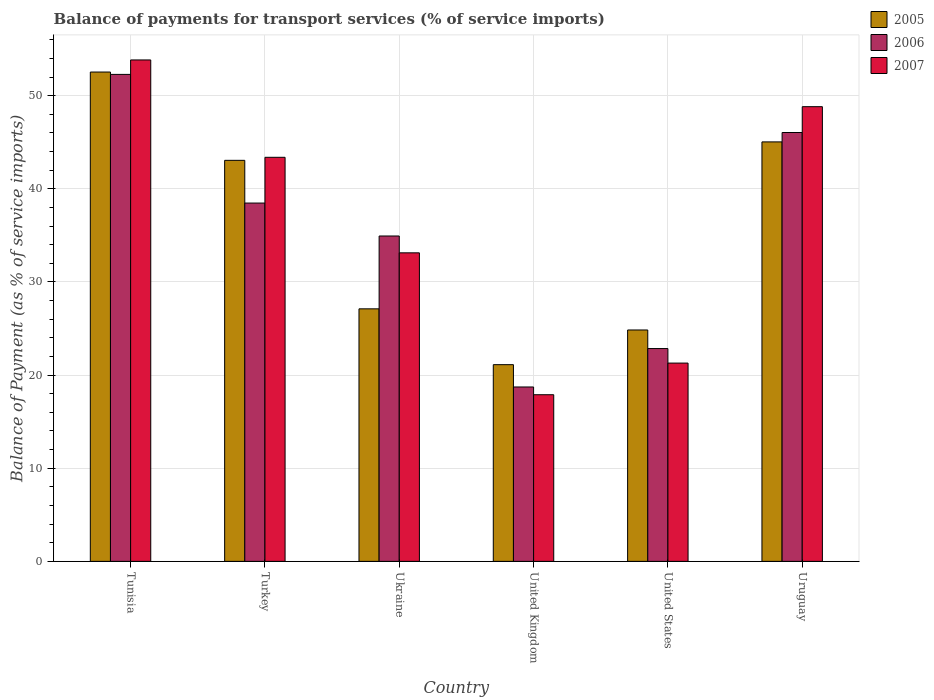How many different coloured bars are there?
Your answer should be compact. 3. Are the number of bars on each tick of the X-axis equal?
Provide a short and direct response. Yes. What is the label of the 6th group of bars from the left?
Keep it short and to the point. Uruguay. What is the balance of payments for transport services in 2007 in Ukraine?
Offer a terse response. 33.13. Across all countries, what is the maximum balance of payments for transport services in 2007?
Provide a short and direct response. 53.84. Across all countries, what is the minimum balance of payments for transport services in 2007?
Provide a succinct answer. 17.89. In which country was the balance of payments for transport services in 2006 maximum?
Your answer should be very brief. Tunisia. In which country was the balance of payments for transport services in 2007 minimum?
Your response must be concise. United Kingdom. What is the total balance of payments for transport services in 2006 in the graph?
Provide a short and direct response. 213.33. What is the difference between the balance of payments for transport services in 2006 in Tunisia and that in United Kingdom?
Your answer should be compact. 33.57. What is the difference between the balance of payments for transport services in 2005 in Uruguay and the balance of payments for transport services in 2006 in United Kingdom?
Your answer should be very brief. 26.32. What is the average balance of payments for transport services in 2007 per country?
Ensure brevity in your answer.  36.39. What is the difference between the balance of payments for transport services of/in 2007 and balance of payments for transport services of/in 2006 in Tunisia?
Provide a short and direct response. 1.55. In how many countries, is the balance of payments for transport services in 2005 greater than 22 %?
Make the answer very short. 5. What is the ratio of the balance of payments for transport services in 2007 in Turkey to that in Ukraine?
Keep it short and to the point. 1.31. Is the difference between the balance of payments for transport services in 2007 in United Kingdom and United States greater than the difference between the balance of payments for transport services in 2006 in United Kingdom and United States?
Provide a short and direct response. Yes. What is the difference between the highest and the second highest balance of payments for transport services in 2006?
Offer a very short reply. -13.82. What is the difference between the highest and the lowest balance of payments for transport services in 2007?
Give a very brief answer. 35.95. In how many countries, is the balance of payments for transport services in 2007 greater than the average balance of payments for transport services in 2007 taken over all countries?
Keep it short and to the point. 3. Is the sum of the balance of payments for transport services in 2005 in Ukraine and United Kingdom greater than the maximum balance of payments for transport services in 2007 across all countries?
Offer a terse response. No. What does the 2nd bar from the left in Uruguay represents?
Give a very brief answer. 2006. What does the 2nd bar from the right in Uruguay represents?
Provide a short and direct response. 2006. Is it the case that in every country, the sum of the balance of payments for transport services in 2006 and balance of payments for transport services in 2007 is greater than the balance of payments for transport services in 2005?
Offer a terse response. Yes. How many bars are there?
Make the answer very short. 18. Are the values on the major ticks of Y-axis written in scientific E-notation?
Your answer should be very brief. No. Does the graph contain any zero values?
Your answer should be compact. No. How many legend labels are there?
Provide a short and direct response. 3. How are the legend labels stacked?
Ensure brevity in your answer.  Vertical. What is the title of the graph?
Offer a terse response. Balance of payments for transport services (% of service imports). Does "2014" appear as one of the legend labels in the graph?
Offer a very short reply. No. What is the label or title of the Y-axis?
Your response must be concise. Balance of Payment (as % of service imports). What is the Balance of Payment (as % of service imports) in 2005 in Tunisia?
Keep it short and to the point. 52.54. What is the Balance of Payment (as % of service imports) in 2006 in Tunisia?
Offer a terse response. 52.29. What is the Balance of Payment (as % of service imports) in 2007 in Tunisia?
Your answer should be very brief. 53.84. What is the Balance of Payment (as % of service imports) in 2005 in Turkey?
Keep it short and to the point. 43.06. What is the Balance of Payment (as % of service imports) of 2006 in Turkey?
Provide a succinct answer. 38.47. What is the Balance of Payment (as % of service imports) of 2007 in Turkey?
Your answer should be very brief. 43.39. What is the Balance of Payment (as % of service imports) of 2005 in Ukraine?
Your answer should be very brief. 27.12. What is the Balance of Payment (as % of service imports) in 2006 in Ukraine?
Make the answer very short. 34.94. What is the Balance of Payment (as % of service imports) in 2007 in Ukraine?
Your answer should be compact. 33.13. What is the Balance of Payment (as % of service imports) of 2005 in United Kingdom?
Provide a short and direct response. 21.12. What is the Balance of Payment (as % of service imports) of 2006 in United Kingdom?
Keep it short and to the point. 18.73. What is the Balance of Payment (as % of service imports) in 2007 in United Kingdom?
Your answer should be very brief. 17.89. What is the Balance of Payment (as % of service imports) of 2005 in United States?
Give a very brief answer. 24.85. What is the Balance of Payment (as % of service imports) of 2006 in United States?
Your answer should be very brief. 22.85. What is the Balance of Payment (as % of service imports) in 2007 in United States?
Provide a short and direct response. 21.29. What is the Balance of Payment (as % of service imports) in 2005 in Uruguay?
Make the answer very short. 45.04. What is the Balance of Payment (as % of service imports) of 2006 in Uruguay?
Offer a very short reply. 46.05. What is the Balance of Payment (as % of service imports) in 2007 in Uruguay?
Give a very brief answer. 48.82. Across all countries, what is the maximum Balance of Payment (as % of service imports) in 2005?
Offer a terse response. 52.54. Across all countries, what is the maximum Balance of Payment (as % of service imports) in 2006?
Make the answer very short. 52.29. Across all countries, what is the maximum Balance of Payment (as % of service imports) in 2007?
Make the answer very short. 53.84. Across all countries, what is the minimum Balance of Payment (as % of service imports) of 2005?
Give a very brief answer. 21.12. Across all countries, what is the minimum Balance of Payment (as % of service imports) of 2006?
Your response must be concise. 18.73. Across all countries, what is the minimum Balance of Payment (as % of service imports) of 2007?
Offer a terse response. 17.89. What is the total Balance of Payment (as % of service imports) of 2005 in the graph?
Make the answer very short. 213.73. What is the total Balance of Payment (as % of service imports) of 2006 in the graph?
Ensure brevity in your answer.  213.33. What is the total Balance of Payment (as % of service imports) of 2007 in the graph?
Your answer should be compact. 218.37. What is the difference between the Balance of Payment (as % of service imports) in 2005 in Tunisia and that in Turkey?
Provide a succinct answer. 9.48. What is the difference between the Balance of Payment (as % of service imports) in 2006 in Tunisia and that in Turkey?
Make the answer very short. 13.82. What is the difference between the Balance of Payment (as % of service imports) of 2007 in Tunisia and that in Turkey?
Your answer should be very brief. 10.45. What is the difference between the Balance of Payment (as % of service imports) in 2005 in Tunisia and that in Ukraine?
Provide a succinct answer. 25.43. What is the difference between the Balance of Payment (as % of service imports) of 2006 in Tunisia and that in Ukraine?
Make the answer very short. 17.35. What is the difference between the Balance of Payment (as % of service imports) in 2007 in Tunisia and that in Ukraine?
Your response must be concise. 20.71. What is the difference between the Balance of Payment (as % of service imports) of 2005 in Tunisia and that in United Kingdom?
Your answer should be very brief. 31.42. What is the difference between the Balance of Payment (as % of service imports) of 2006 in Tunisia and that in United Kingdom?
Ensure brevity in your answer.  33.56. What is the difference between the Balance of Payment (as % of service imports) in 2007 in Tunisia and that in United Kingdom?
Make the answer very short. 35.95. What is the difference between the Balance of Payment (as % of service imports) of 2005 in Tunisia and that in United States?
Provide a short and direct response. 27.7. What is the difference between the Balance of Payment (as % of service imports) in 2006 in Tunisia and that in United States?
Keep it short and to the point. 29.44. What is the difference between the Balance of Payment (as % of service imports) of 2007 in Tunisia and that in United States?
Offer a very short reply. 32.55. What is the difference between the Balance of Payment (as % of service imports) of 2005 in Tunisia and that in Uruguay?
Ensure brevity in your answer.  7.5. What is the difference between the Balance of Payment (as % of service imports) in 2006 in Tunisia and that in Uruguay?
Your response must be concise. 6.24. What is the difference between the Balance of Payment (as % of service imports) of 2007 in Tunisia and that in Uruguay?
Offer a terse response. 5.02. What is the difference between the Balance of Payment (as % of service imports) in 2005 in Turkey and that in Ukraine?
Make the answer very short. 15.95. What is the difference between the Balance of Payment (as % of service imports) in 2006 in Turkey and that in Ukraine?
Keep it short and to the point. 3.54. What is the difference between the Balance of Payment (as % of service imports) in 2007 in Turkey and that in Ukraine?
Provide a short and direct response. 10.26. What is the difference between the Balance of Payment (as % of service imports) in 2005 in Turkey and that in United Kingdom?
Provide a succinct answer. 21.94. What is the difference between the Balance of Payment (as % of service imports) of 2006 in Turkey and that in United Kingdom?
Your answer should be very brief. 19.75. What is the difference between the Balance of Payment (as % of service imports) in 2007 in Turkey and that in United Kingdom?
Provide a short and direct response. 25.49. What is the difference between the Balance of Payment (as % of service imports) in 2005 in Turkey and that in United States?
Offer a terse response. 18.22. What is the difference between the Balance of Payment (as % of service imports) in 2006 in Turkey and that in United States?
Provide a short and direct response. 15.62. What is the difference between the Balance of Payment (as % of service imports) in 2007 in Turkey and that in United States?
Your answer should be compact. 22.1. What is the difference between the Balance of Payment (as % of service imports) of 2005 in Turkey and that in Uruguay?
Offer a terse response. -1.98. What is the difference between the Balance of Payment (as % of service imports) of 2006 in Turkey and that in Uruguay?
Keep it short and to the point. -7.58. What is the difference between the Balance of Payment (as % of service imports) of 2007 in Turkey and that in Uruguay?
Your answer should be compact. -5.44. What is the difference between the Balance of Payment (as % of service imports) in 2005 in Ukraine and that in United Kingdom?
Your response must be concise. 5.99. What is the difference between the Balance of Payment (as % of service imports) of 2006 in Ukraine and that in United Kingdom?
Your answer should be very brief. 16.21. What is the difference between the Balance of Payment (as % of service imports) in 2007 in Ukraine and that in United Kingdom?
Offer a very short reply. 15.24. What is the difference between the Balance of Payment (as % of service imports) of 2005 in Ukraine and that in United States?
Keep it short and to the point. 2.27. What is the difference between the Balance of Payment (as % of service imports) in 2006 in Ukraine and that in United States?
Ensure brevity in your answer.  12.09. What is the difference between the Balance of Payment (as % of service imports) in 2007 in Ukraine and that in United States?
Your response must be concise. 11.84. What is the difference between the Balance of Payment (as % of service imports) of 2005 in Ukraine and that in Uruguay?
Your answer should be compact. -17.93. What is the difference between the Balance of Payment (as % of service imports) of 2006 in Ukraine and that in Uruguay?
Provide a succinct answer. -11.11. What is the difference between the Balance of Payment (as % of service imports) of 2007 in Ukraine and that in Uruguay?
Make the answer very short. -15.69. What is the difference between the Balance of Payment (as % of service imports) of 2005 in United Kingdom and that in United States?
Your answer should be compact. -3.72. What is the difference between the Balance of Payment (as % of service imports) of 2006 in United Kingdom and that in United States?
Ensure brevity in your answer.  -4.13. What is the difference between the Balance of Payment (as % of service imports) of 2007 in United Kingdom and that in United States?
Provide a succinct answer. -3.4. What is the difference between the Balance of Payment (as % of service imports) of 2005 in United Kingdom and that in Uruguay?
Your answer should be very brief. -23.92. What is the difference between the Balance of Payment (as % of service imports) of 2006 in United Kingdom and that in Uruguay?
Offer a very short reply. -27.32. What is the difference between the Balance of Payment (as % of service imports) in 2007 in United Kingdom and that in Uruguay?
Provide a succinct answer. -30.93. What is the difference between the Balance of Payment (as % of service imports) in 2005 in United States and that in Uruguay?
Provide a succinct answer. -20.2. What is the difference between the Balance of Payment (as % of service imports) of 2006 in United States and that in Uruguay?
Offer a terse response. -23.2. What is the difference between the Balance of Payment (as % of service imports) in 2007 in United States and that in Uruguay?
Your answer should be very brief. -27.53. What is the difference between the Balance of Payment (as % of service imports) in 2005 in Tunisia and the Balance of Payment (as % of service imports) in 2006 in Turkey?
Make the answer very short. 14.07. What is the difference between the Balance of Payment (as % of service imports) in 2005 in Tunisia and the Balance of Payment (as % of service imports) in 2007 in Turkey?
Give a very brief answer. 9.16. What is the difference between the Balance of Payment (as % of service imports) in 2006 in Tunisia and the Balance of Payment (as % of service imports) in 2007 in Turkey?
Your response must be concise. 8.9. What is the difference between the Balance of Payment (as % of service imports) in 2005 in Tunisia and the Balance of Payment (as % of service imports) in 2006 in Ukraine?
Give a very brief answer. 17.61. What is the difference between the Balance of Payment (as % of service imports) of 2005 in Tunisia and the Balance of Payment (as % of service imports) of 2007 in Ukraine?
Keep it short and to the point. 19.41. What is the difference between the Balance of Payment (as % of service imports) of 2006 in Tunisia and the Balance of Payment (as % of service imports) of 2007 in Ukraine?
Your answer should be very brief. 19.16. What is the difference between the Balance of Payment (as % of service imports) of 2005 in Tunisia and the Balance of Payment (as % of service imports) of 2006 in United Kingdom?
Ensure brevity in your answer.  33.82. What is the difference between the Balance of Payment (as % of service imports) of 2005 in Tunisia and the Balance of Payment (as % of service imports) of 2007 in United Kingdom?
Give a very brief answer. 34.65. What is the difference between the Balance of Payment (as % of service imports) in 2006 in Tunisia and the Balance of Payment (as % of service imports) in 2007 in United Kingdom?
Offer a very short reply. 34.4. What is the difference between the Balance of Payment (as % of service imports) in 2005 in Tunisia and the Balance of Payment (as % of service imports) in 2006 in United States?
Offer a terse response. 29.69. What is the difference between the Balance of Payment (as % of service imports) of 2005 in Tunisia and the Balance of Payment (as % of service imports) of 2007 in United States?
Provide a succinct answer. 31.25. What is the difference between the Balance of Payment (as % of service imports) of 2006 in Tunisia and the Balance of Payment (as % of service imports) of 2007 in United States?
Provide a short and direct response. 31. What is the difference between the Balance of Payment (as % of service imports) of 2005 in Tunisia and the Balance of Payment (as % of service imports) of 2006 in Uruguay?
Your answer should be very brief. 6.49. What is the difference between the Balance of Payment (as % of service imports) in 2005 in Tunisia and the Balance of Payment (as % of service imports) in 2007 in Uruguay?
Your answer should be compact. 3.72. What is the difference between the Balance of Payment (as % of service imports) in 2006 in Tunisia and the Balance of Payment (as % of service imports) in 2007 in Uruguay?
Offer a very short reply. 3.47. What is the difference between the Balance of Payment (as % of service imports) of 2005 in Turkey and the Balance of Payment (as % of service imports) of 2006 in Ukraine?
Make the answer very short. 8.13. What is the difference between the Balance of Payment (as % of service imports) of 2005 in Turkey and the Balance of Payment (as % of service imports) of 2007 in Ukraine?
Your answer should be compact. 9.93. What is the difference between the Balance of Payment (as % of service imports) of 2006 in Turkey and the Balance of Payment (as % of service imports) of 2007 in Ukraine?
Make the answer very short. 5.34. What is the difference between the Balance of Payment (as % of service imports) of 2005 in Turkey and the Balance of Payment (as % of service imports) of 2006 in United Kingdom?
Your answer should be very brief. 24.34. What is the difference between the Balance of Payment (as % of service imports) of 2005 in Turkey and the Balance of Payment (as % of service imports) of 2007 in United Kingdom?
Ensure brevity in your answer.  25.17. What is the difference between the Balance of Payment (as % of service imports) in 2006 in Turkey and the Balance of Payment (as % of service imports) in 2007 in United Kingdom?
Your response must be concise. 20.58. What is the difference between the Balance of Payment (as % of service imports) in 2005 in Turkey and the Balance of Payment (as % of service imports) in 2006 in United States?
Your answer should be compact. 20.21. What is the difference between the Balance of Payment (as % of service imports) of 2005 in Turkey and the Balance of Payment (as % of service imports) of 2007 in United States?
Your answer should be compact. 21.77. What is the difference between the Balance of Payment (as % of service imports) in 2006 in Turkey and the Balance of Payment (as % of service imports) in 2007 in United States?
Your answer should be very brief. 17.18. What is the difference between the Balance of Payment (as % of service imports) of 2005 in Turkey and the Balance of Payment (as % of service imports) of 2006 in Uruguay?
Your response must be concise. -2.99. What is the difference between the Balance of Payment (as % of service imports) of 2005 in Turkey and the Balance of Payment (as % of service imports) of 2007 in Uruguay?
Ensure brevity in your answer.  -5.76. What is the difference between the Balance of Payment (as % of service imports) of 2006 in Turkey and the Balance of Payment (as % of service imports) of 2007 in Uruguay?
Your answer should be compact. -10.35. What is the difference between the Balance of Payment (as % of service imports) of 2005 in Ukraine and the Balance of Payment (as % of service imports) of 2006 in United Kingdom?
Provide a succinct answer. 8.39. What is the difference between the Balance of Payment (as % of service imports) of 2005 in Ukraine and the Balance of Payment (as % of service imports) of 2007 in United Kingdom?
Your answer should be very brief. 9.22. What is the difference between the Balance of Payment (as % of service imports) of 2006 in Ukraine and the Balance of Payment (as % of service imports) of 2007 in United Kingdom?
Offer a terse response. 17.04. What is the difference between the Balance of Payment (as % of service imports) in 2005 in Ukraine and the Balance of Payment (as % of service imports) in 2006 in United States?
Your answer should be very brief. 4.26. What is the difference between the Balance of Payment (as % of service imports) of 2005 in Ukraine and the Balance of Payment (as % of service imports) of 2007 in United States?
Keep it short and to the point. 5.82. What is the difference between the Balance of Payment (as % of service imports) in 2006 in Ukraine and the Balance of Payment (as % of service imports) in 2007 in United States?
Your answer should be compact. 13.65. What is the difference between the Balance of Payment (as % of service imports) of 2005 in Ukraine and the Balance of Payment (as % of service imports) of 2006 in Uruguay?
Give a very brief answer. -18.93. What is the difference between the Balance of Payment (as % of service imports) of 2005 in Ukraine and the Balance of Payment (as % of service imports) of 2007 in Uruguay?
Offer a very short reply. -21.71. What is the difference between the Balance of Payment (as % of service imports) in 2006 in Ukraine and the Balance of Payment (as % of service imports) in 2007 in Uruguay?
Ensure brevity in your answer.  -13.89. What is the difference between the Balance of Payment (as % of service imports) in 2005 in United Kingdom and the Balance of Payment (as % of service imports) in 2006 in United States?
Give a very brief answer. -1.73. What is the difference between the Balance of Payment (as % of service imports) of 2005 in United Kingdom and the Balance of Payment (as % of service imports) of 2007 in United States?
Provide a short and direct response. -0.17. What is the difference between the Balance of Payment (as % of service imports) in 2006 in United Kingdom and the Balance of Payment (as % of service imports) in 2007 in United States?
Offer a very short reply. -2.57. What is the difference between the Balance of Payment (as % of service imports) in 2005 in United Kingdom and the Balance of Payment (as % of service imports) in 2006 in Uruguay?
Your response must be concise. -24.93. What is the difference between the Balance of Payment (as % of service imports) in 2005 in United Kingdom and the Balance of Payment (as % of service imports) in 2007 in Uruguay?
Ensure brevity in your answer.  -27.7. What is the difference between the Balance of Payment (as % of service imports) of 2006 in United Kingdom and the Balance of Payment (as % of service imports) of 2007 in Uruguay?
Your answer should be very brief. -30.1. What is the difference between the Balance of Payment (as % of service imports) in 2005 in United States and the Balance of Payment (as % of service imports) in 2006 in Uruguay?
Make the answer very short. -21.2. What is the difference between the Balance of Payment (as % of service imports) of 2005 in United States and the Balance of Payment (as % of service imports) of 2007 in Uruguay?
Keep it short and to the point. -23.98. What is the difference between the Balance of Payment (as % of service imports) in 2006 in United States and the Balance of Payment (as % of service imports) in 2007 in Uruguay?
Give a very brief answer. -25.97. What is the average Balance of Payment (as % of service imports) in 2005 per country?
Provide a short and direct response. 35.62. What is the average Balance of Payment (as % of service imports) of 2006 per country?
Keep it short and to the point. 35.55. What is the average Balance of Payment (as % of service imports) of 2007 per country?
Ensure brevity in your answer.  36.39. What is the difference between the Balance of Payment (as % of service imports) of 2005 and Balance of Payment (as % of service imports) of 2006 in Tunisia?
Give a very brief answer. 0.25. What is the difference between the Balance of Payment (as % of service imports) in 2005 and Balance of Payment (as % of service imports) in 2007 in Tunisia?
Provide a succinct answer. -1.3. What is the difference between the Balance of Payment (as % of service imports) of 2006 and Balance of Payment (as % of service imports) of 2007 in Tunisia?
Give a very brief answer. -1.55. What is the difference between the Balance of Payment (as % of service imports) in 2005 and Balance of Payment (as % of service imports) in 2006 in Turkey?
Offer a terse response. 4.59. What is the difference between the Balance of Payment (as % of service imports) of 2005 and Balance of Payment (as % of service imports) of 2007 in Turkey?
Offer a terse response. -0.33. What is the difference between the Balance of Payment (as % of service imports) in 2006 and Balance of Payment (as % of service imports) in 2007 in Turkey?
Provide a succinct answer. -4.91. What is the difference between the Balance of Payment (as % of service imports) in 2005 and Balance of Payment (as % of service imports) in 2006 in Ukraine?
Your answer should be compact. -7.82. What is the difference between the Balance of Payment (as % of service imports) in 2005 and Balance of Payment (as % of service imports) in 2007 in Ukraine?
Give a very brief answer. -6.01. What is the difference between the Balance of Payment (as % of service imports) in 2006 and Balance of Payment (as % of service imports) in 2007 in Ukraine?
Your answer should be compact. 1.81. What is the difference between the Balance of Payment (as % of service imports) of 2005 and Balance of Payment (as % of service imports) of 2006 in United Kingdom?
Ensure brevity in your answer.  2.4. What is the difference between the Balance of Payment (as % of service imports) of 2005 and Balance of Payment (as % of service imports) of 2007 in United Kingdom?
Give a very brief answer. 3.23. What is the difference between the Balance of Payment (as % of service imports) in 2006 and Balance of Payment (as % of service imports) in 2007 in United Kingdom?
Ensure brevity in your answer.  0.83. What is the difference between the Balance of Payment (as % of service imports) in 2005 and Balance of Payment (as % of service imports) in 2006 in United States?
Make the answer very short. 2. What is the difference between the Balance of Payment (as % of service imports) of 2005 and Balance of Payment (as % of service imports) of 2007 in United States?
Your answer should be compact. 3.55. What is the difference between the Balance of Payment (as % of service imports) in 2006 and Balance of Payment (as % of service imports) in 2007 in United States?
Offer a terse response. 1.56. What is the difference between the Balance of Payment (as % of service imports) in 2005 and Balance of Payment (as % of service imports) in 2006 in Uruguay?
Make the answer very short. -1.01. What is the difference between the Balance of Payment (as % of service imports) in 2005 and Balance of Payment (as % of service imports) in 2007 in Uruguay?
Provide a succinct answer. -3.78. What is the difference between the Balance of Payment (as % of service imports) in 2006 and Balance of Payment (as % of service imports) in 2007 in Uruguay?
Your answer should be very brief. -2.77. What is the ratio of the Balance of Payment (as % of service imports) of 2005 in Tunisia to that in Turkey?
Keep it short and to the point. 1.22. What is the ratio of the Balance of Payment (as % of service imports) in 2006 in Tunisia to that in Turkey?
Offer a very short reply. 1.36. What is the ratio of the Balance of Payment (as % of service imports) of 2007 in Tunisia to that in Turkey?
Your answer should be compact. 1.24. What is the ratio of the Balance of Payment (as % of service imports) of 2005 in Tunisia to that in Ukraine?
Keep it short and to the point. 1.94. What is the ratio of the Balance of Payment (as % of service imports) in 2006 in Tunisia to that in Ukraine?
Give a very brief answer. 1.5. What is the ratio of the Balance of Payment (as % of service imports) in 2007 in Tunisia to that in Ukraine?
Keep it short and to the point. 1.63. What is the ratio of the Balance of Payment (as % of service imports) of 2005 in Tunisia to that in United Kingdom?
Provide a succinct answer. 2.49. What is the ratio of the Balance of Payment (as % of service imports) in 2006 in Tunisia to that in United Kingdom?
Offer a terse response. 2.79. What is the ratio of the Balance of Payment (as % of service imports) in 2007 in Tunisia to that in United Kingdom?
Make the answer very short. 3.01. What is the ratio of the Balance of Payment (as % of service imports) in 2005 in Tunisia to that in United States?
Offer a very short reply. 2.11. What is the ratio of the Balance of Payment (as % of service imports) in 2006 in Tunisia to that in United States?
Your answer should be very brief. 2.29. What is the ratio of the Balance of Payment (as % of service imports) in 2007 in Tunisia to that in United States?
Your answer should be very brief. 2.53. What is the ratio of the Balance of Payment (as % of service imports) of 2005 in Tunisia to that in Uruguay?
Provide a short and direct response. 1.17. What is the ratio of the Balance of Payment (as % of service imports) in 2006 in Tunisia to that in Uruguay?
Provide a short and direct response. 1.14. What is the ratio of the Balance of Payment (as % of service imports) in 2007 in Tunisia to that in Uruguay?
Your answer should be very brief. 1.1. What is the ratio of the Balance of Payment (as % of service imports) in 2005 in Turkey to that in Ukraine?
Your answer should be compact. 1.59. What is the ratio of the Balance of Payment (as % of service imports) in 2006 in Turkey to that in Ukraine?
Make the answer very short. 1.1. What is the ratio of the Balance of Payment (as % of service imports) of 2007 in Turkey to that in Ukraine?
Offer a terse response. 1.31. What is the ratio of the Balance of Payment (as % of service imports) in 2005 in Turkey to that in United Kingdom?
Your response must be concise. 2.04. What is the ratio of the Balance of Payment (as % of service imports) in 2006 in Turkey to that in United Kingdom?
Your response must be concise. 2.05. What is the ratio of the Balance of Payment (as % of service imports) of 2007 in Turkey to that in United Kingdom?
Keep it short and to the point. 2.42. What is the ratio of the Balance of Payment (as % of service imports) in 2005 in Turkey to that in United States?
Keep it short and to the point. 1.73. What is the ratio of the Balance of Payment (as % of service imports) of 2006 in Turkey to that in United States?
Give a very brief answer. 1.68. What is the ratio of the Balance of Payment (as % of service imports) in 2007 in Turkey to that in United States?
Offer a very short reply. 2.04. What is the ratio of the Balance of Payment (as % of service imports) in 2005 in Turkey to that in Uruguay?
Your answer should be compact. 0.96. What is the ratio of the Balance of Payment (as % of service imports) of 2006 in Turkey to that in Uruguay?
Offer a terse response. 0.84. What is the ratio of the Balance of Payment (as % of service imports) of 2007 in Turkey to that in Uruguay?
Offer a terse response. 0.89. What is the ratio of the Balance of Payment (as % of service imports) of 2005 in Ukraine to that in United Kingdom?
Ensure brevity in your answer.  1.28. What is the ratio of the Balance of Payment (as % of service imports) in 2006 in Ukraine to that in United Kingdom?
Your answer should be compact. 1.87. What is the ratio of the Balance of Payment (as % of service imports) of 2007 in Ukraine to that in United Kingdom?
Offer a terse response. 1.85. What is the ratio of the Balance of Payment (as % of service imports) of 2005 in Ukraine to that in United States?
Your answer should be very brief. 1.09. What is the ratio of the Balance of Payment (as % of service imports) in 2006 in Ukraine to that in United States?
Offer a terse response. 1.53. What is the ratio of the Balance of Payment (as % of service imports) of 2007 in Ukraine to that in United States?
Provide a short and direct response. 1.56. What is the ratio of the Balance of Payment (as % of service imports) in 2005 in Ukraine to that in Uruguay?
Make the answer very short. 0.6. What is the ratio of the Balance of Payment (as % of service imports) of 2006 in Ukraine to that in Uruguay?
Offer a terse response. 0.76. What is the ratio of the Balance of Payment (as % of service imports) of 2007 in Ukraine to that in Uruguay?
Offer a very short reply. 0.68. What is the ratio of the Balance of Payment (as % of service imports) in 2005 in United Kingdom to that in United States?
Your answer should be compact. 0.85. What is the ratio of the Balance of Payment (as % of service imports) of 2006 in United Kingdom to that in United States?
Provide a short and direct response. 0.82. What is the ratio of the Balance of Payment (as % of service imports) of 2007 in United Kingdom to that in United States?
Keep it short and to the point. 0.84. What is the ratio of the Balance of Payment (as % of service imports) of 2005 in United Kingdom to that in Uruguay?
Make the answer very short. 0.47. What is the ratio of the Balance of Payment (as % of service imports) in 2006 in United Kingdom to that in Uruguay?
Your answer should be very brief. 0.41. What is the ratio of the Balance of Payment (as % of service imports) in 2007 in United Kingdom to that in Uruguay?
Offer a terse response. 0.37. What is the ratio of the Balance of Payment (as % of service imports) in 2005 in United States to that in Uruguay?
Provide a succinct answer. 0.55. What is the ratio of the Balance of Payment (as % of service imports) of 2006 in United States to that in Uruguay?
Keep it short and to the point. 0.5. What is the ratio of the Balance of Payment (as % of service imports) of 2007 in United States to that in Uruguay?
Your response must be concise. 0.44. What is the difference between the highest and the second highest Balance of Payment (as % of service imports) in 2005?
Your response must be concise. 7.5. What is the difference between the highest and the second highest Balance of Payment (as % of service imports) in 2006?
Keep it short and to the point. 6.24. What is the difference between the highest and the second highest Balance of Payment (as % of service imports) in 2007?
Provide a short and direct response. 5.02. What is the difference between the highest and the lowest Balance of Payment (as % of service imports) of 2005?
Offer a very short reply. 31.42. What is the difference between the highest and the lowest Balance of Payment (as % of service imports) of 2006?
Provide a succinct answer. 33.56. What is the difference between the highest and the lowest Balance of Payment (as % of service imports) in 2007?
Provide a short and direct response. 35.95. 